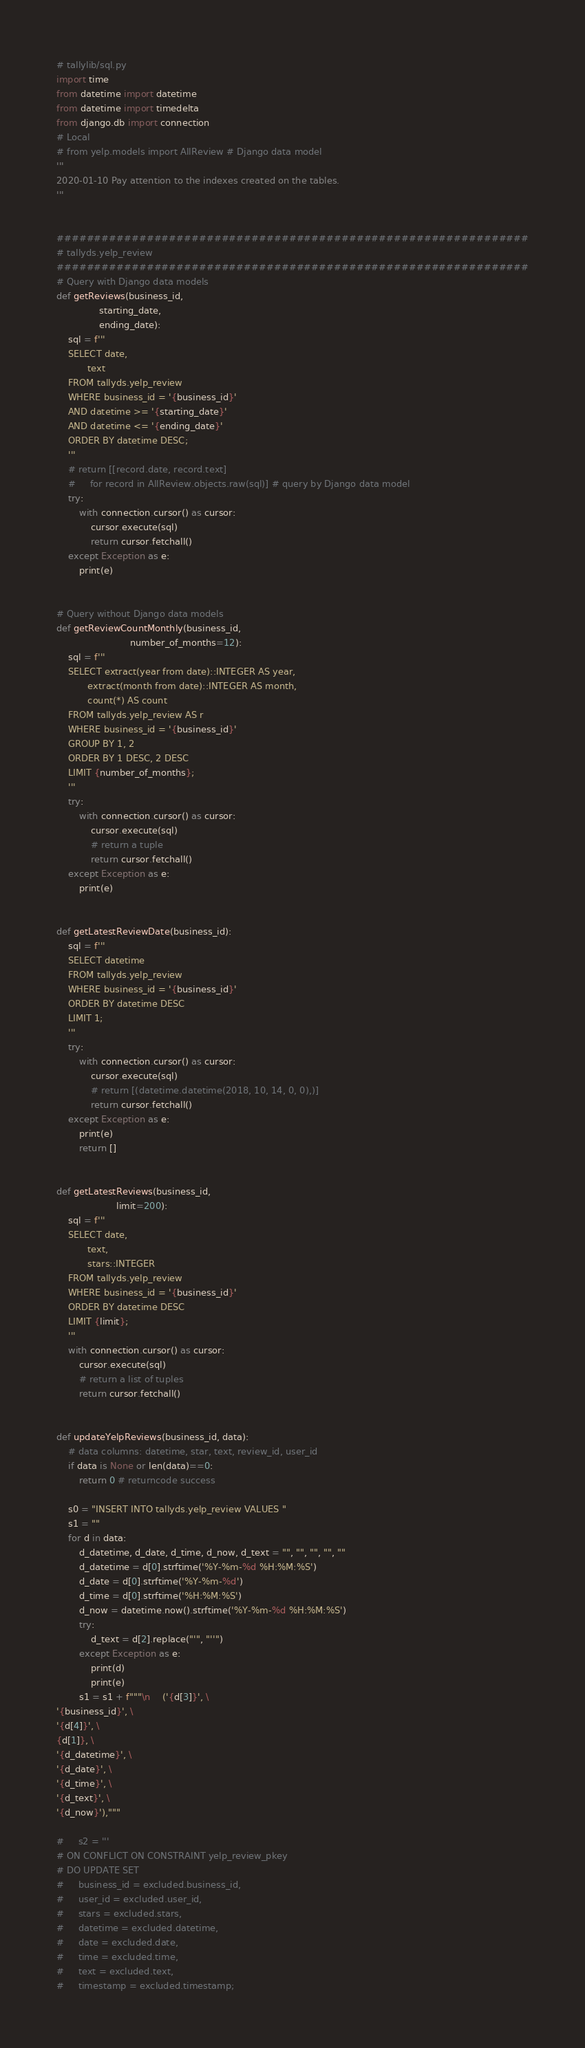<code> <loc_0><loc_0><loc_500><loc_500><_Python_># tallylib/sql.py
import time
from datetime import datetime
from datetime import timedelta
from django.db import connection
# Local
# from yelp.models import AllReview # Django data model
'''
2020-01-10 Pay attention to the indexes created on the tables.
'''


###############################################################
# tallyds.yelp_review
###############################################################
# Query with Django data models
def getReviews(business_id, 
               starting_date, 
               ending_date):
    sql = f'''
    SELECT date, 
           text 
    FROM tallyds.yelp_review
    WHERE business_id = '{business_id}'
    AND datetime >= '{starting_date}'
    AND datetime <= '{ending_date}'
    ORDER BY datetime DESC;
    '''
    # return [[record.date, record.text] 
    #     for record in AllReview.objects.raw(sql)] # query by Django data model
    try:
        with connection.cursor() as cursor:
            cursor.execute(sql)
            return cursor.fetchall()
    except Exception as e:
        print(e)


# Query without Django data models
def getReviewCountMonthly(business_id,
                          number_of_months=12):
    sql = f'''
    SELECT extract(year from date)::INTEGER AS year,
           extract(month from date)::INTEGER AS month,
           count(*) AS count
    FROM tallyds.yelp_review AS r
    WHERE business_id = '{business_id}'
    GROUP BY 1, 2
    ORDER BY 1 DESC, 2 DESC
    LIMIT {number_of_months};
    '''
    try:
        with connection.cursor() as cursor:
            cursor.execute(sql)
            # return a tuple
            return cursor.fetchall()
    except Exception as e:
        print(e)

    
def getLatestReviewDate(business_id):
    sql = f'''
    SELECT datetime
    FROM tallyds.yelp_review
    WHERE business_id = '{business_id}'
    ORDER BY datetime DESC
    LIMIT 1;
    '''
    try:
        with connection.cursor() as cursor:
            cursor.execute(sql)
            # return [(datetime.datetime(2018, 10, 14, 0, 0),)]
            return cursor.fetchall()
    except Exception as e:
        print(e)
        return []


def getLatestReviews(business_id, 
                     limit=200):
    sql = f'''
    SELECT date, 
           text,
           stars::INTEGER
    FROM tallyds.yelp_review
    WHERE business_id = '{business_id}'
    ORDER BY datetime DESC
    LIMIT {limit};
    '''
    with connection.cursor() as cursor:
        cursor.execute(sql)
        # return a list of tuples
        return cursor.fetchall()


def updateYelpReviews(business_id, data):
    # data columns: datetime, star, text, review_id, user_id
    if data is None or len(data)==0:
        return 0 # returncode success

    s0 = "INSERT INTO tallyds.yelp_review VALUES "
    s1 = ""
    for d in data:
        d_datetime, d_date, d_time, d_now, d_text = "", "", "", "", ""
        d_datetime = d[0].strftime('%Y-%m-%d %H:%M:%S')
        d_date = d[0].strftime('%Y-%m-%d')
        d_time = d[0].strftime('%H:%M:%S')
        d_now = datetime.now().strftime('%Y-%m-%d %H:%M:%S')
        try:
            d_text = d[2].replace("'", "''")
        except Exception as e:
            print(d)
            print(e)
        s1 = s1 + f"""\n    ('{d[3]}', \
'{business_id}', \
'{d[4]}', \
{d[1]}, \
'{d_datetime}', \
'{d_date}', \
'{d_time}', \
'{d_text}', \
'{d_now}'),"""

#     s2 = '''
# ON CONFLICT ON CONSTRAINT yelp_review_pkey
# DO UPDATE SET
#     business_id = excluded.business_id,
#     user_id = excluded.user_id,
#     stars = excluded.stars,
#     datetime = excluded.datetime,
#     date = excluded.date,
#     time = excluded.time,
#     text = excluded.text,
#     timestamp = excluded.timestamp;    </code> 